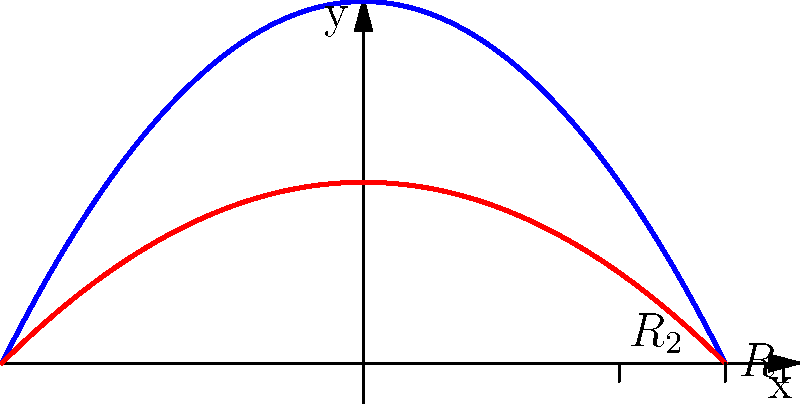In a pipe with varying diameter, the velocity profiles of fluid flow in two sections are shown above. If the flow rate is constant throughout the pipe, which section has the larger diameter, and why? To determine which section has the larger diameter, we need to consider the relationship between flow rate, velocity, and cross-sectional area:

1. The flow rate (Q) is constant throughout the pipe and is given by:
   $Q = A_1v_{avg1} = A_2v_{avg2}$, where A is the cross-sectional area and $v_{avg}$ is the average velocity.

2. The average velocity is proportional to the maximum velocity at the center of the pipe:
   $v_{avg} = k \cdot v_{max}$, where k is a constant (typically around 0.5 for laminar flow).

3. From the graph, we can see that $v_{max1} > v_{max2}$.

4. Since $Q = A_1v_{avg1} = A_2v_{avg2}$ and $v_{avg1} > v_{avg2}$, we can conclude that $A_2 > A_1$.

5. The cross-sectional area of a circular pipe is proportional to the square of its radius:
   $A = \pi R^2$

6. Therefore, the section with the larger cross-sectional area (A2) must have a larger radius (R2).

In the graph, R2 is shown to be smaller than R1, which is inconsistent with our conclusion. This visual representation is incorrect, and R2 should actually be larger than R1.
Answer: The section with velocity profile $v_2(r)$ has the larger diameter. 